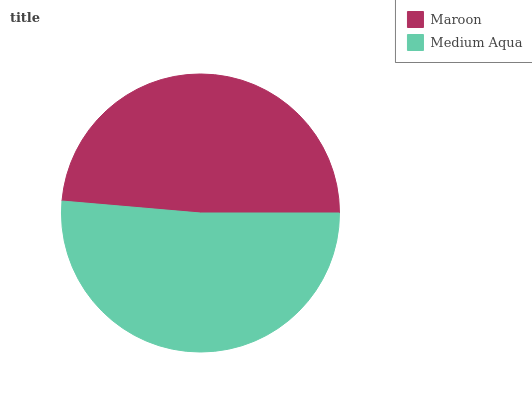Is Maroon the minimum?
Answer yes or no. Yes. Is Medium Aqua the maximum?
Answer yes or no. Yes. Is Medium Aqua the minimum?
Answer yes or no. No. Is Medium Aqua greater than Maroon?
Answer yes or no. Yes. Is Maroon less than Medium Aqua?
Answer yes or no. Yes. Is Maroon greater than Medium Aqua?
Answer yes or no. No. Is Medium Aqua less than Maroon?
Answer yes or no. No. Is Medium Aqua the high median?
Answer yes or no. Yes. Is Maroon the low median?
Answer yes or no. Yes. Is Maroon the high median?
Answer yes or no. No. Is Medium Aqua the low median?
Answer yes or no. No. 